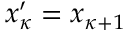Convert formula to latex. <formula><loc_0><loc_0><loc_500><loc_500>x _ { \kappa } ^ { \prime } = x _ { \kappa + 1 }</formula> 